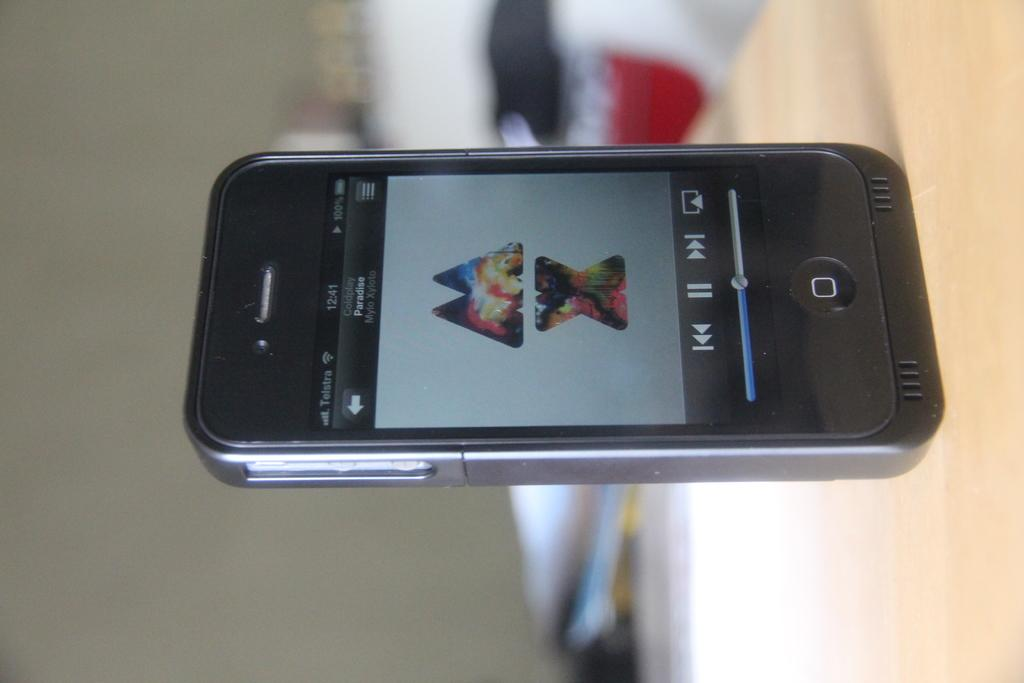<image>
Give a short and clear explanation of the subsequent image. a cell phone open to a screen playing Coldplay Paradise 